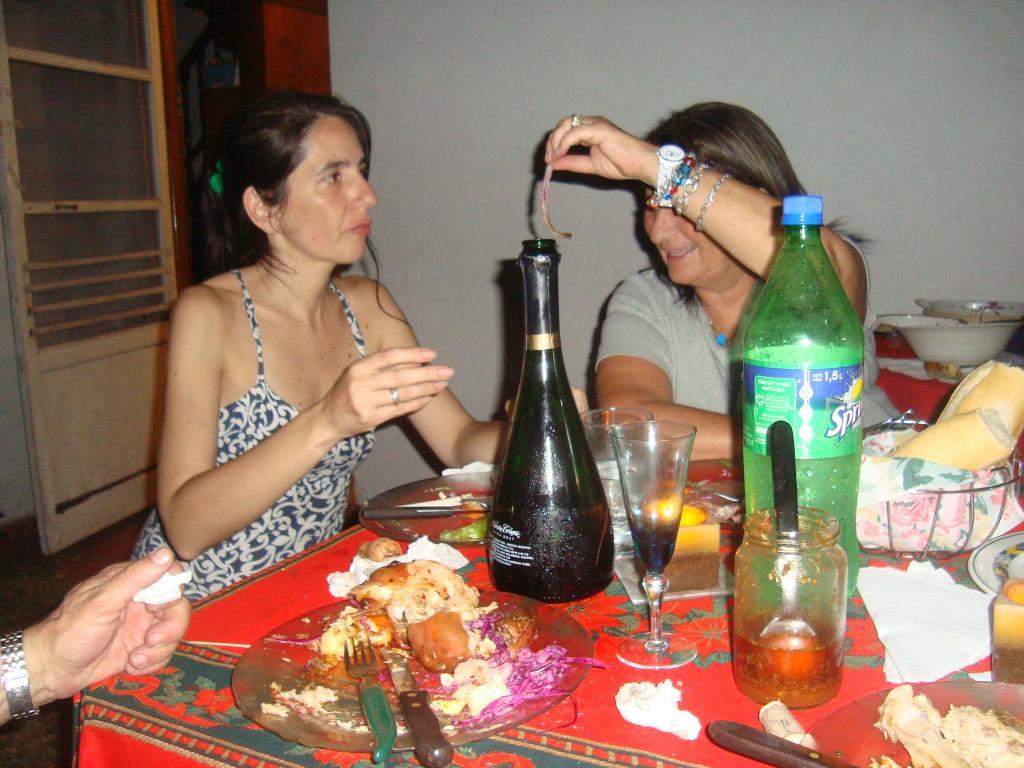What brand of soda is on the table?
Keep it short and to the point. Sprite. 